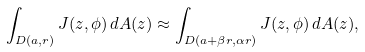Convert formula to latex. <formula><loc_0><loc_0><loc_500><loc_500>\int _ { D ( a , r ) } J ( z , \phi ) \, d A ( z ) \approx \int _ { D ( a + \beta r , \alpha r ) } J ( z , \phi ) \, d A ( z ) ,</formula> 